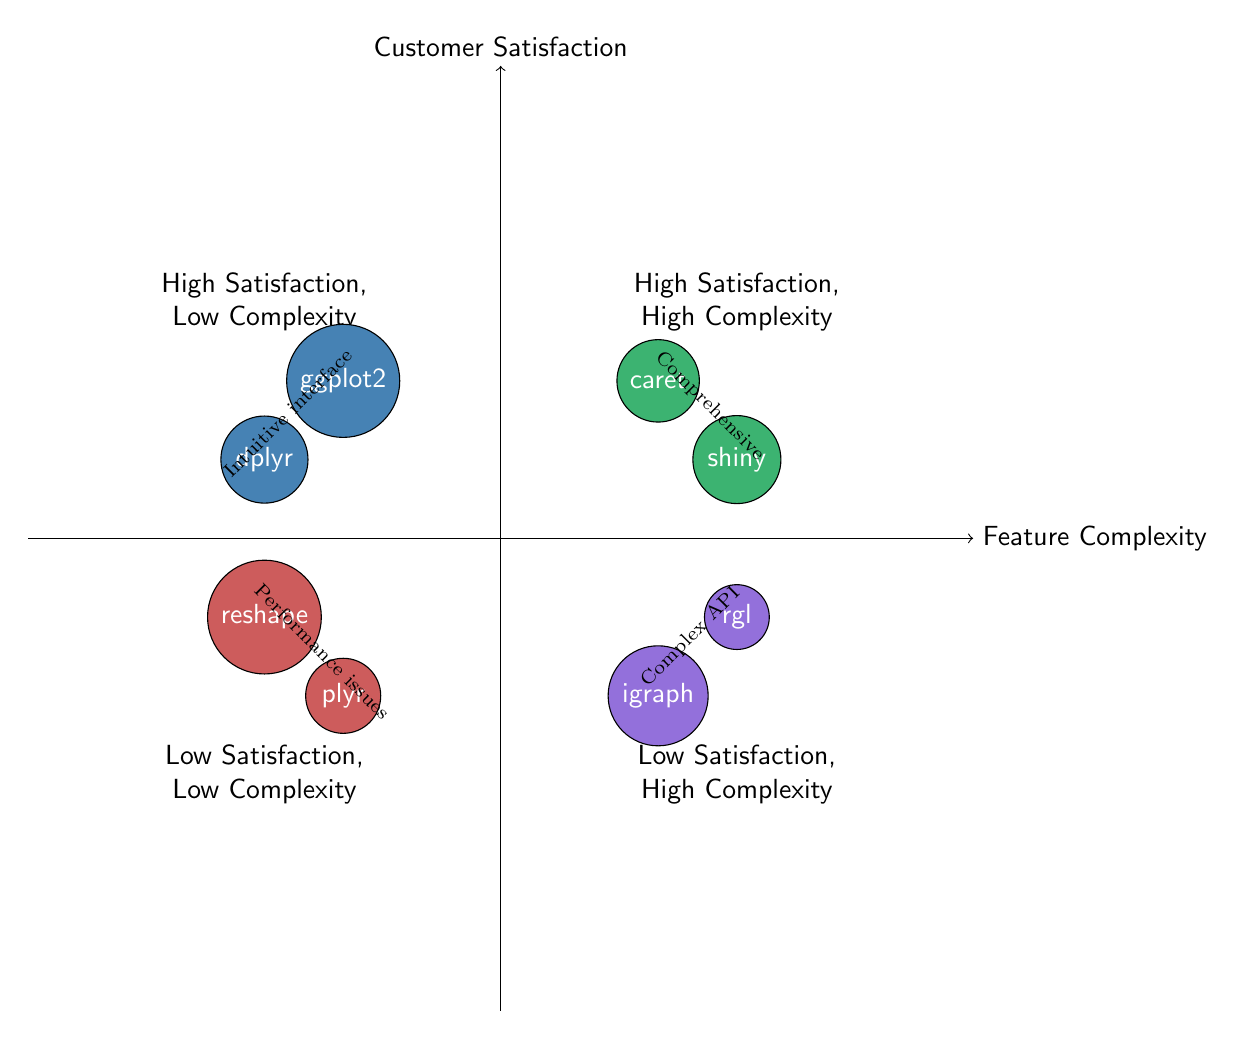What packages are in the High Satisfaction, Low Complexity quadrant? The High Satisfaction, Low Complexity quadrant contains the packages ggplot2 and dplyr, which are positioned in the upper left section of the diagram.
Answer: ggplot2, dplyr How many packages are in the Low Satisfaction, High Complexity quadrant? The Low Satisfaction, High Complexity quadrant includes the packages igraph and rgl, giving a total count of two packages in this section of the diagram.
Answer: 2 What is the primary drawback of the plyr package? The diagram specifies that the plyr package is often criticized for performance issues, as noted by the connecting label in the Low Satisfaction, Low Complexity quadrant.
Answer: Performance issues Which package offers comprehensive functionalities but has a steep learning curve? The caretaker package falls into the High Satisfaction, High Complexity quadrant, and is described as being valued for its comprehensiveness but with a notable learning curve.
Answer: caret Which quadrant contains both high satisfaction and low complexity? The upper left quadrant of the diagram denotes high satisfaction and low complexity, which is explicitly labeled as High Satisfaction, Low Complexity.
Answer: High Satisfaction, Low Complexity What is the relationship between igraph and rgl? Both igraph and rgl are positioned in the Low Satisfaction, High Complexity quadrant; a connecting label indicates that igraph offers advanced tools with steep learning requirements, while rgl has a complex API.
Answer: Complex API Which quadrant contains packages that are simple but criticized? The packages plyr and reshape fall into the Low Satisfaction, Low Complexity quadrant, indicating that they are simple yet criticized for their limitations.
Answer: Low Satisfaction, Low Complexity How does the satisfaction level change from dplyr to igraph? Transitioning from dplyr in the High Satisfaction, Low Complexity quadrant to igraph in the Low Satisfaction, High Complexity quadrant represents a shift from high satisfaction to low satisfaction, indicating potential user dissatisfaction with increased complexity.
Answer: High to Low Satisfaction 